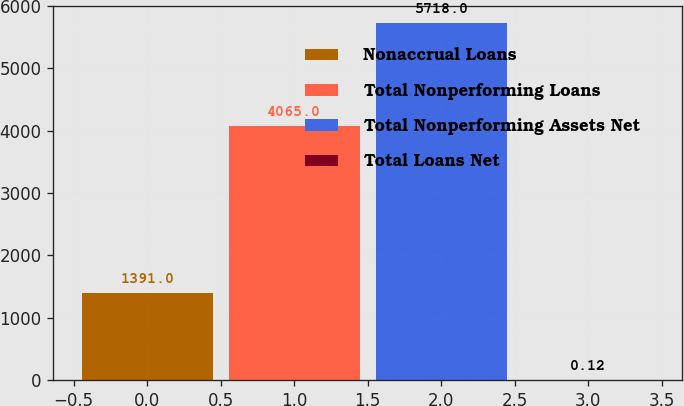Convert chart to OTSL. <chart><loc_0><loc_0><loc_500><loc_500><bar_chart><fcel>Nonaccrual Loans<fcel>Total Nonperforming Loans<fcel>Total Nonperforming Assets Net<fcel>Total Loans Net<nl><fcel>1391<fcel>4065<fcel>5718<fcel>0.12<nl></chart> 